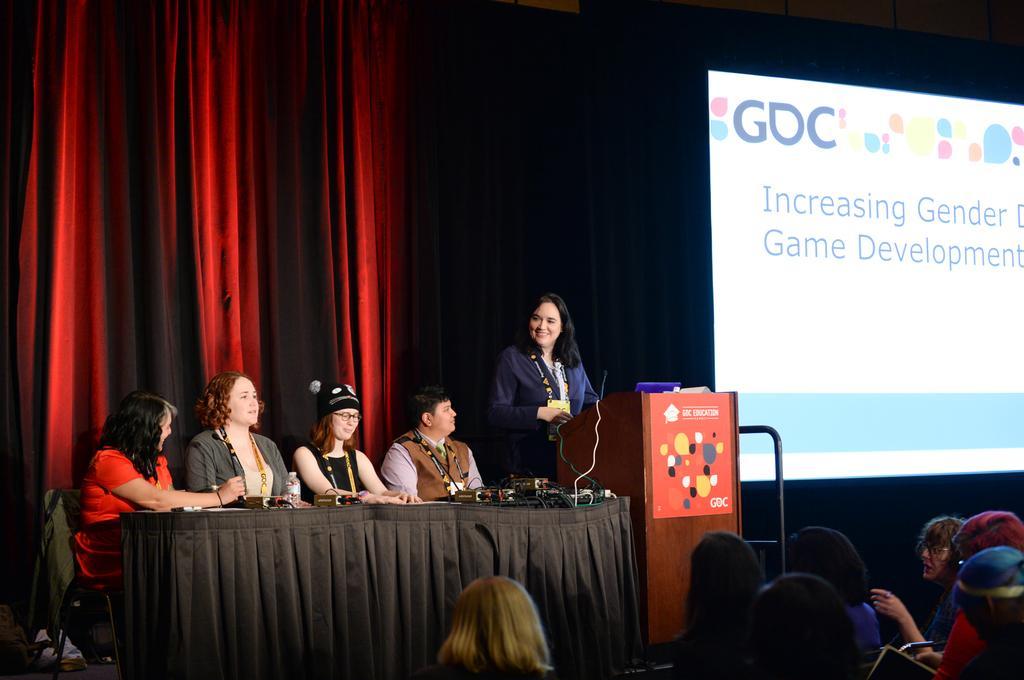How would you summarize this image in a sentence or two? In this picture, we see four women are sitting. In front of them, we see a table which is covered with black color sheet. On the table, we see water bottle, books and cables. Beside them, we see a woman in blue blazer is standing in front of the podium. She is smiling. Behind her, we see a red color sheet. In the right bottom of the picture, we see people. On the right side, we see a projector screen which is displaying something and in the background, it is black in color. 